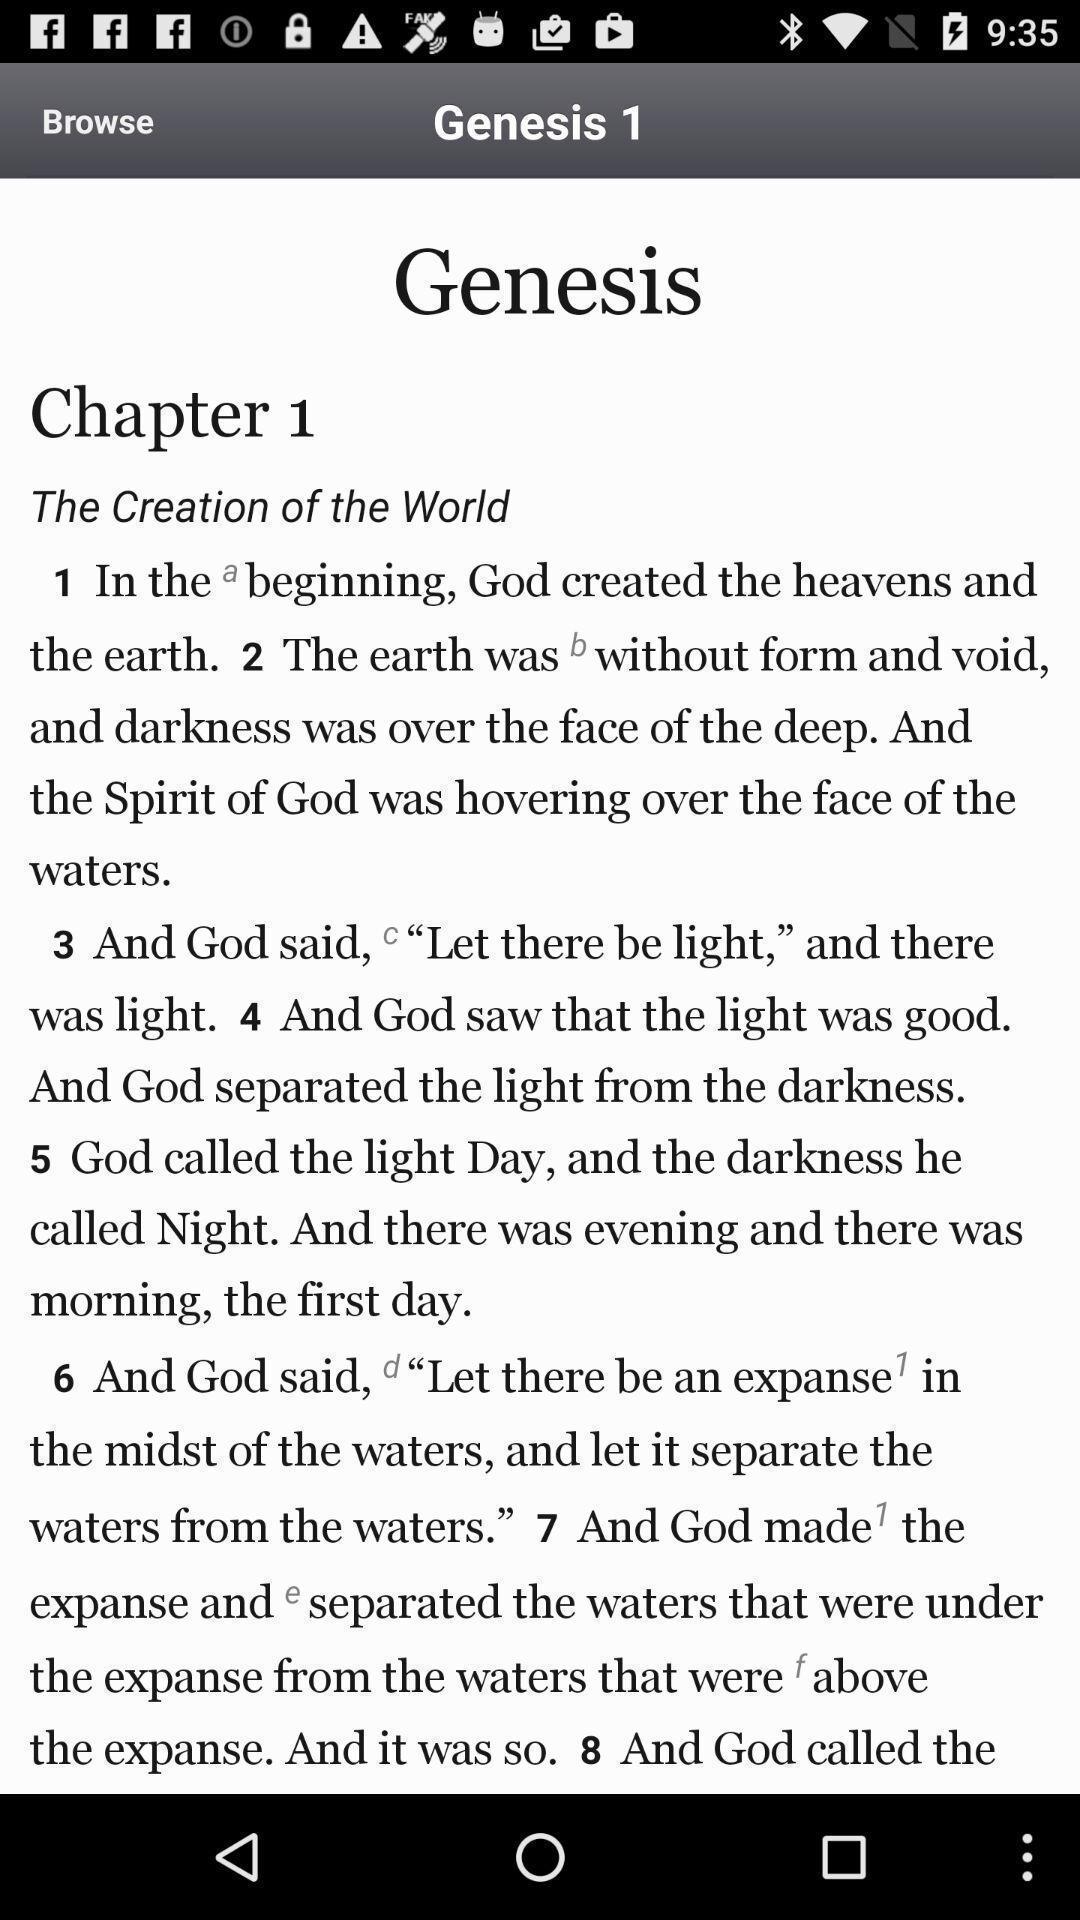Explain the elements present in this screenshot. Page from the digital book of genesis. 